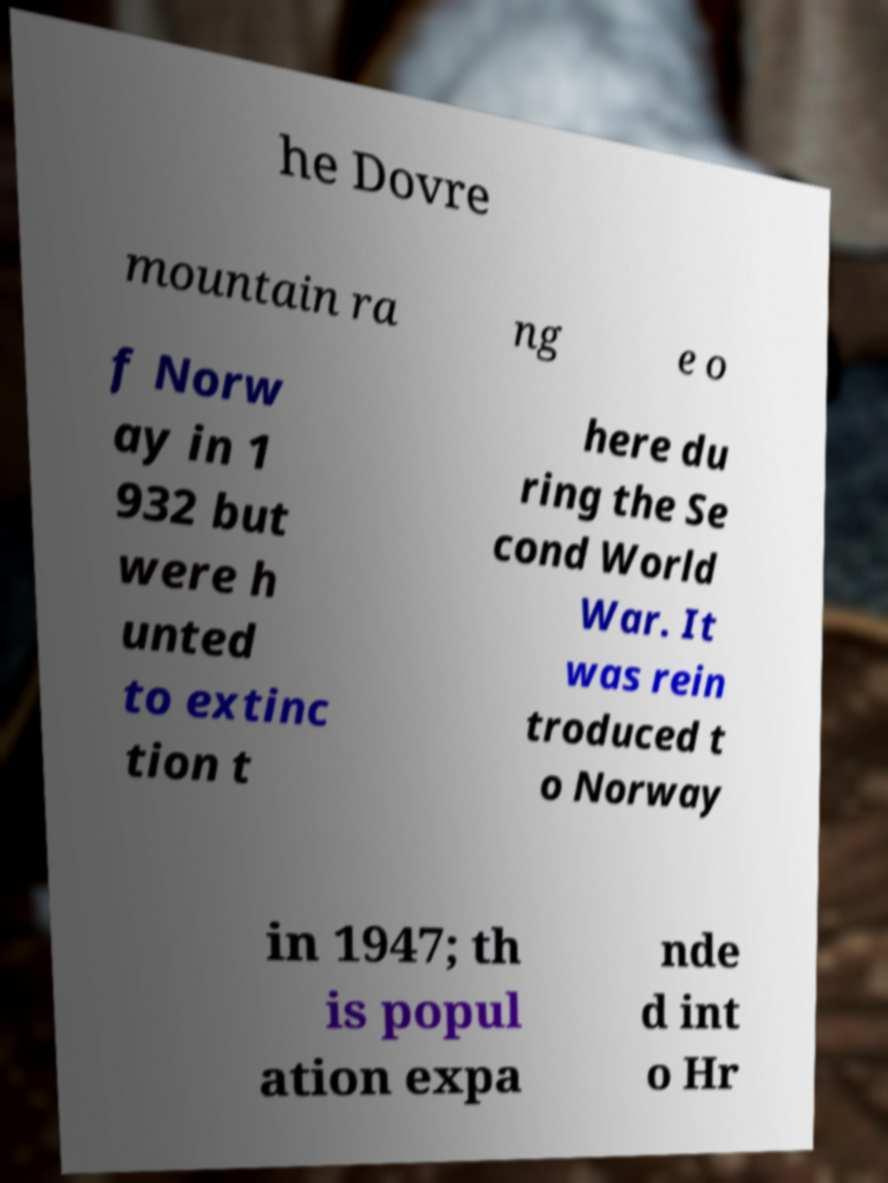Could you extract and type out the text from this image? he Dovre mountain ra ng e o f Norw ay in 1 932 but were h unted to extinc tion t here du ring the Se cond World War. It was rein troduced t o Norway in 1947; th is popul ation expa nde d int o Hr 